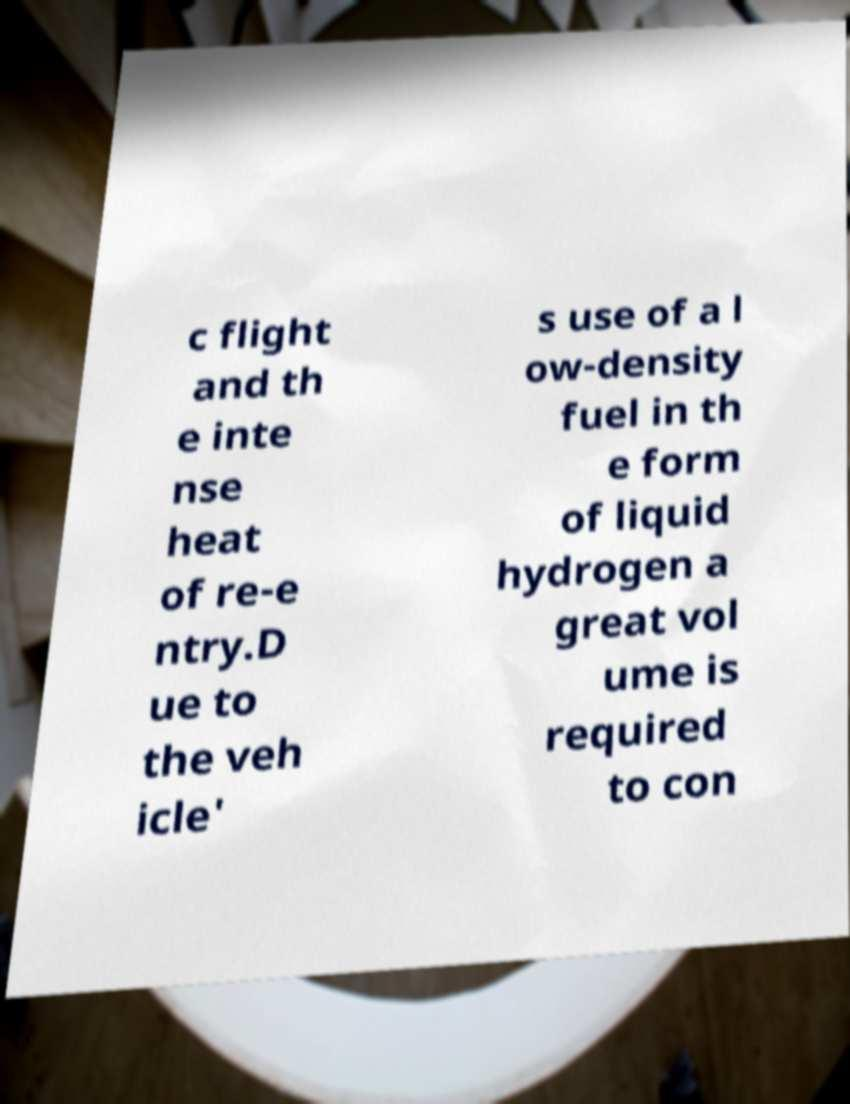I need the written content from this picture converted into text. Can you do that? c flight and th e inte nse heat of re-e ntry.D ue to the veh icle' s use of a l ow-density fuel in th e form of liquid hydrogen a great vol ume is required to con 